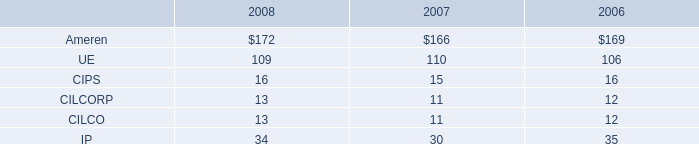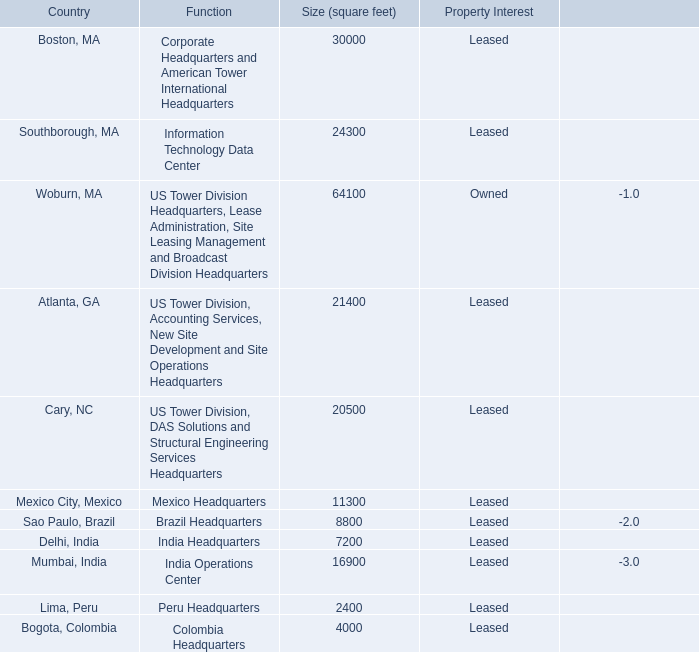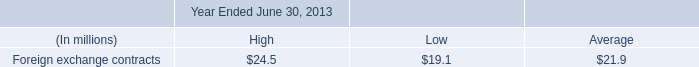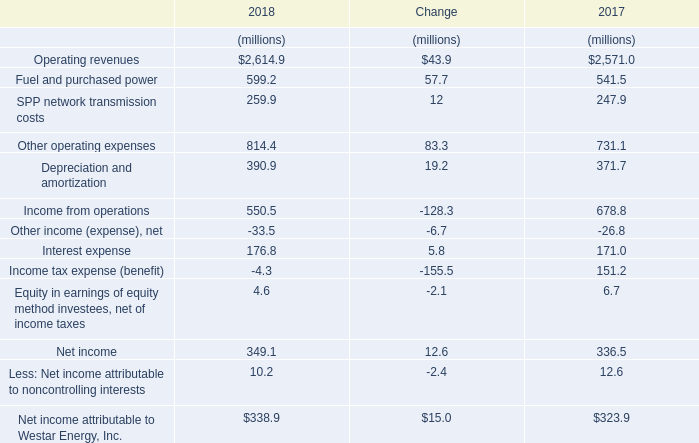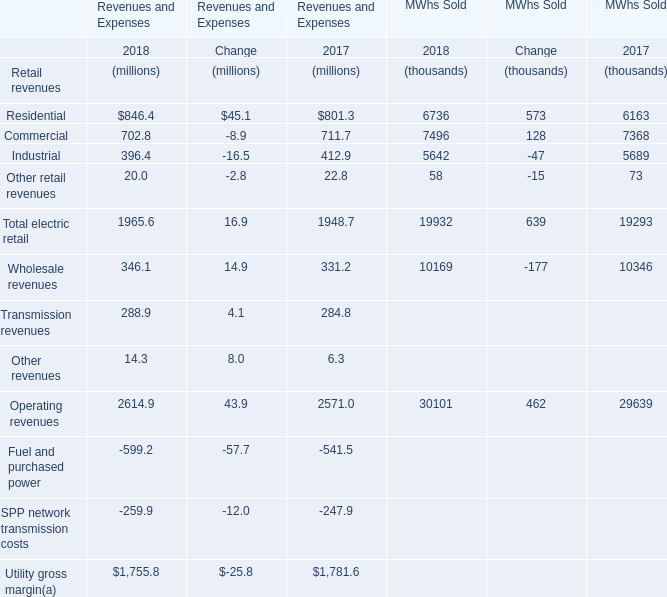What was the average value of the Commercial for Revenues and Expenses in the years where Residential is positive? (in million) 
Computations: ((702.8 + 711.7) / 2)
Answer: 707.25. 